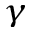Convert formula to latex. <formula><loc_0><loc_0><loc_500><loc_500>_ { \gamma }</formula> 